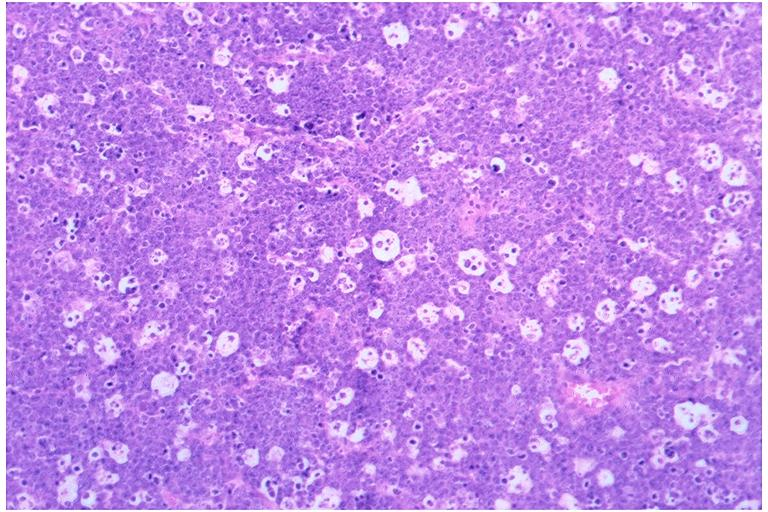what does this image show?
Answer the question using a single word or phrase. Burkits lymphoma 